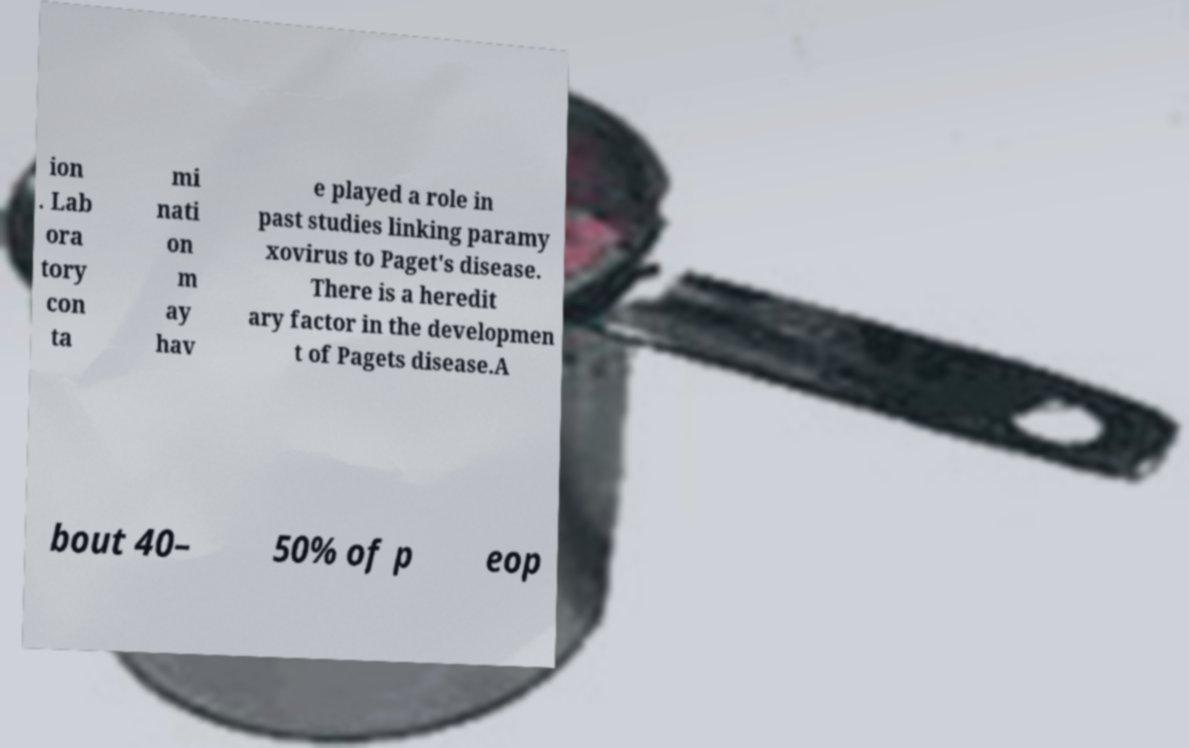Please identify and transcribe the text found in this image. ion . Lab ora tory con ta mi nati on m ay hav e played a role in past studies linking paramy xovirus to Paget's disease. There is a heredit ary factor in the developmen t of Pagets disease.A bout 40– 50% of p eop 